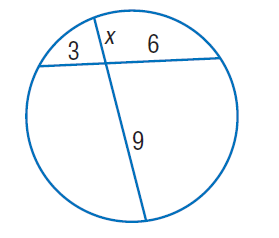Question: Find x. Round to the nearest tenth if necessary.
Choices:
A. 2
B. 3
C. 6
D. 9
Answer with the letter. Answer: A 